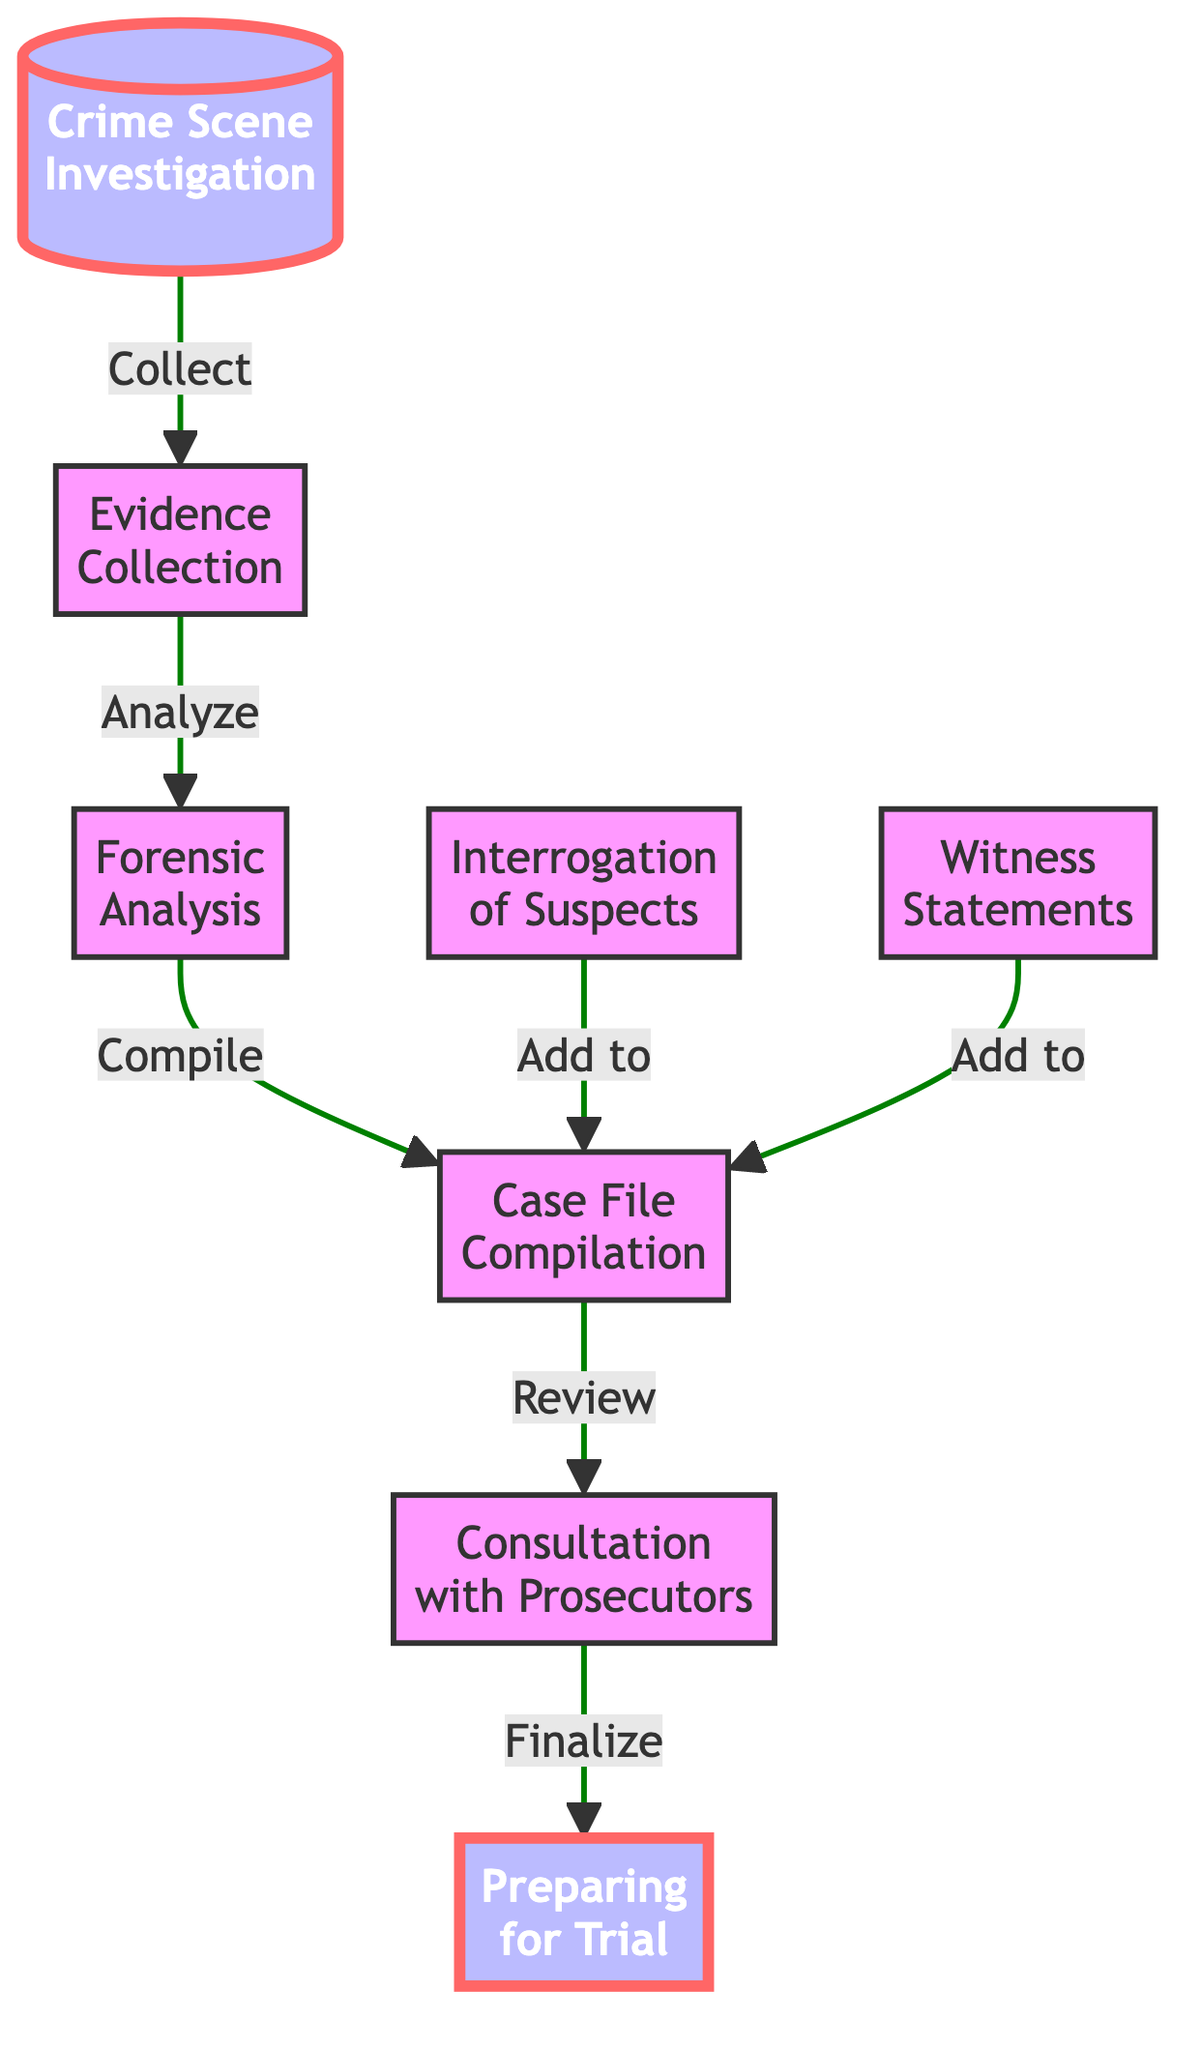What is the first step in the flow of evidence collection? The first step indicated in the diagram is labeled "Crime Scene Investigation." This is where the initial assessment and collection of evidence begin.
Answer: Crime Scene Investigation How many main steps are shown in the flow chart? By counting the nodes in the diagram, there are a total of eight main steps in the flow chart.
Answer: Eight What is the relationship between "Evidence Collection" and "Forensic Analysis"? The diagram shows that "Evidence Collection" is directly linked to "Forensic Analysis" with the arrow indicating the flow proceeds from the collection of evidence to its analysis.
Answer: Analyze What is added to the "Case File Compilation"? Both "Interrogation of Suspects" and "Witness Statements" add information to the "Case File Compilation," indicating that these inputs are crucial for building a comprehensive case.
Answer: Interrogation of Suspects and Witness Statements What step comes after "Consultation with Prosecutors"? According to the flow chart, "Preparing for Trial" directly follows "Consultation with Prosecutors," showcasing the sequential progress toward trial preparations.
Answer: Preparing for Trial Which two components flow into the "Case File Compilation"? The two components that flow into the "Case File Compilation" are "Interrogation of Suspects" and "Witness Statements," emphasizing the importance of both in compiling case files.
Answer: Interrogation of Suspects and Witness Statements What action leads from "Forensic Analysis" to "Case File Compilation"? The action that leads from "Forensic Analysis" to "Case File Compilation" is labeled "Compile," indicating that the results from the analysis are integrated into the case file.
Answer: Compile Which node is highlighted as special in the diagram? The nodes highlighted as special are "Crime Scene Investigation" and "Preparing for Trial," which indicates their critical importance in the evidence flow process.
Answer: Crime Scene Investigation and Preparing for Trial What is reviewed during the "Consultation with Prosecutors"? The diagram indicates that the "Consultation with Prosecutors" step involves reviewing evidence and strategies, essential for the preparation of the case.
Answer: Evidence and strategies 